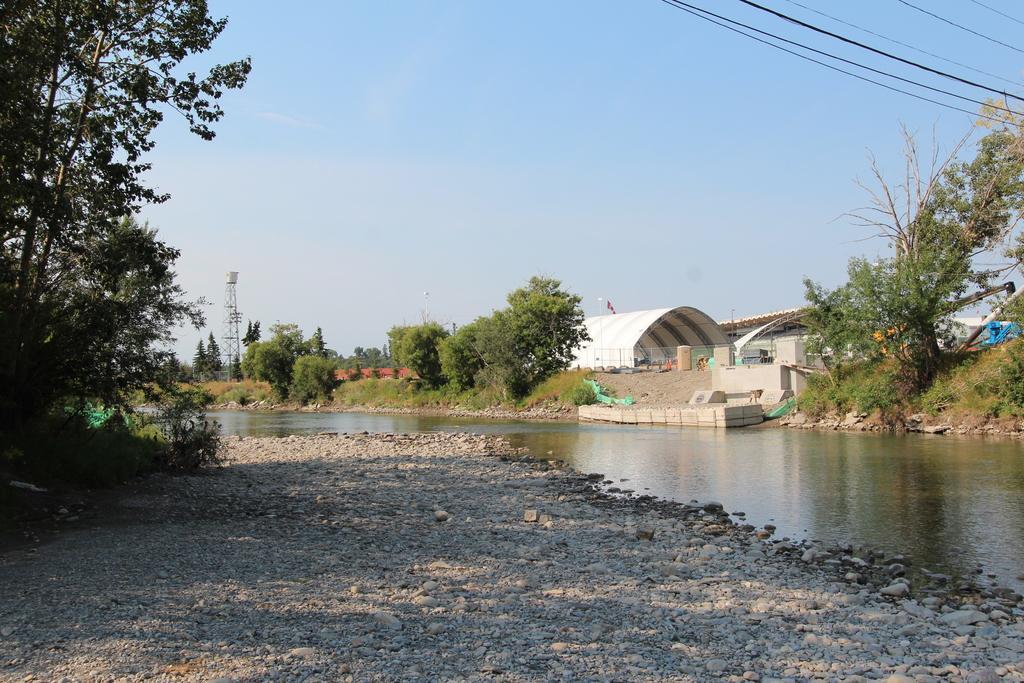Please provide a concise description of this image. In this image there are trees and we can see a tunnel. At the bottom there are stones and we can see water. In the background there is a tower, sky and wires. 